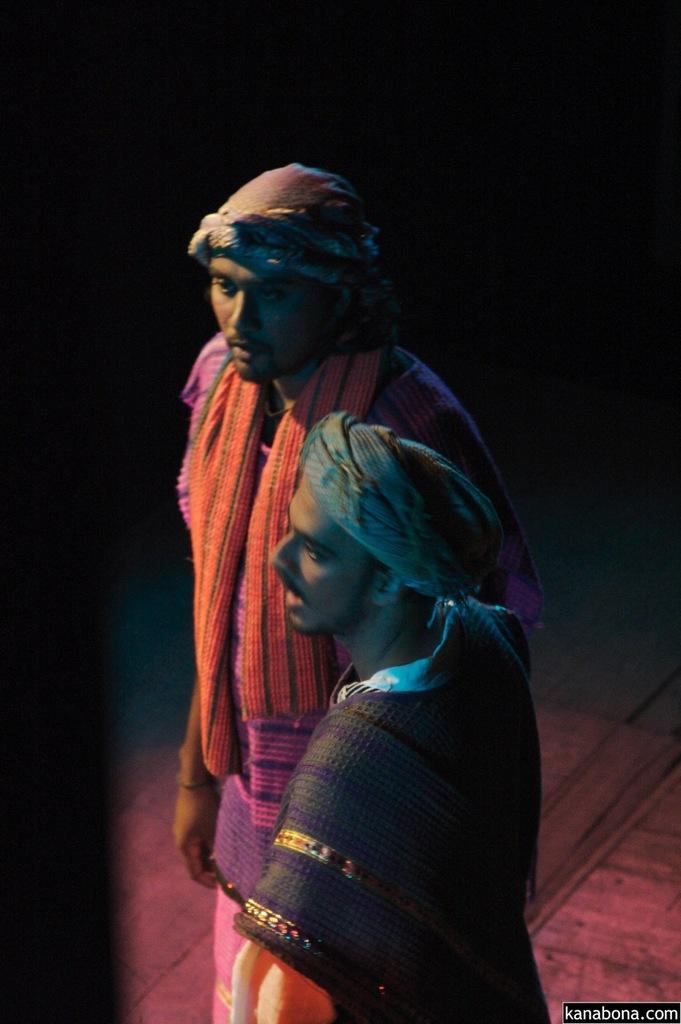How many people are in the image? There are two people in the image. What are the people doing in the image? The two people are standing. Can you describe the background of the image? The background of the image is dark. What type of coat is the doll wearing in the image? There is no doll present in the image, so it cannot be determined what type of coat the doll might be wearing. 